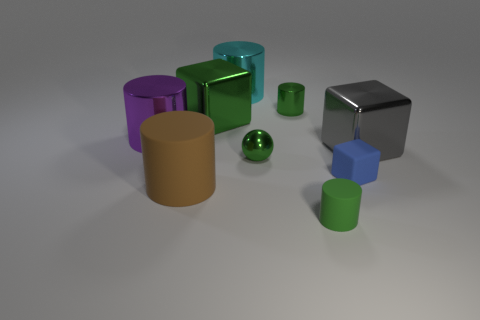What number of red objects are tiny objects or spheres?
Your response must be concise. 0. The other cube that is the same material as the large green block is what color?
Offer a terse response. Gray. Is there any other thing that has the same size as the metallic sphere?
Offer a terse response. Yes. What number of big things are either purple things or gray blocks?
Your response must be concise. 2. Are there fewer large metal spheres than big brown things?
Provide a short and direct response. Yes. There is another matte thing that is the same shape as the tiny green rubber thing; what is its color?
Your answer should be compact. Brown. Is there any other thing that has the same shape as the tiny blue thing?
Keep it short and to the point. Yes. Are there more green cylinders than big gray things?
Give a very brief answer. Yes. How many other things are the same material as the big gray block?
Offer a very short reply. 5. There is a tiny shiny thing that is in front of the cube that is behind the large metal object on the right side of the blue thing; what is its shape?
Ensure brevity in your answer.  Sphere. 